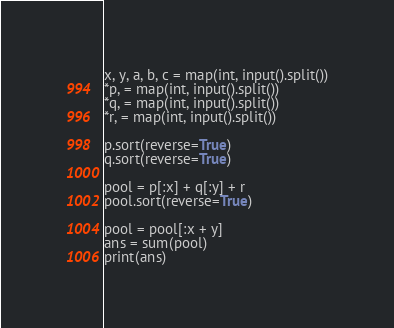Convert code to text. <code><loc_0><loc_0><loc_500><loc_500><_Python_>x, y, a, b, c = map(int, input().split())
*p, = map(int, input().split())
*q, = map(int, input().split())
*r, = map(int, input().split())

p.sort(reverse=True)
q.sort(reverse=True)

pool = p[:x] + q[:y] + r
pool.sort(reverse=True)

pool = pool[:x + y]
ans = sum(pool)
print(ans)
</code> 